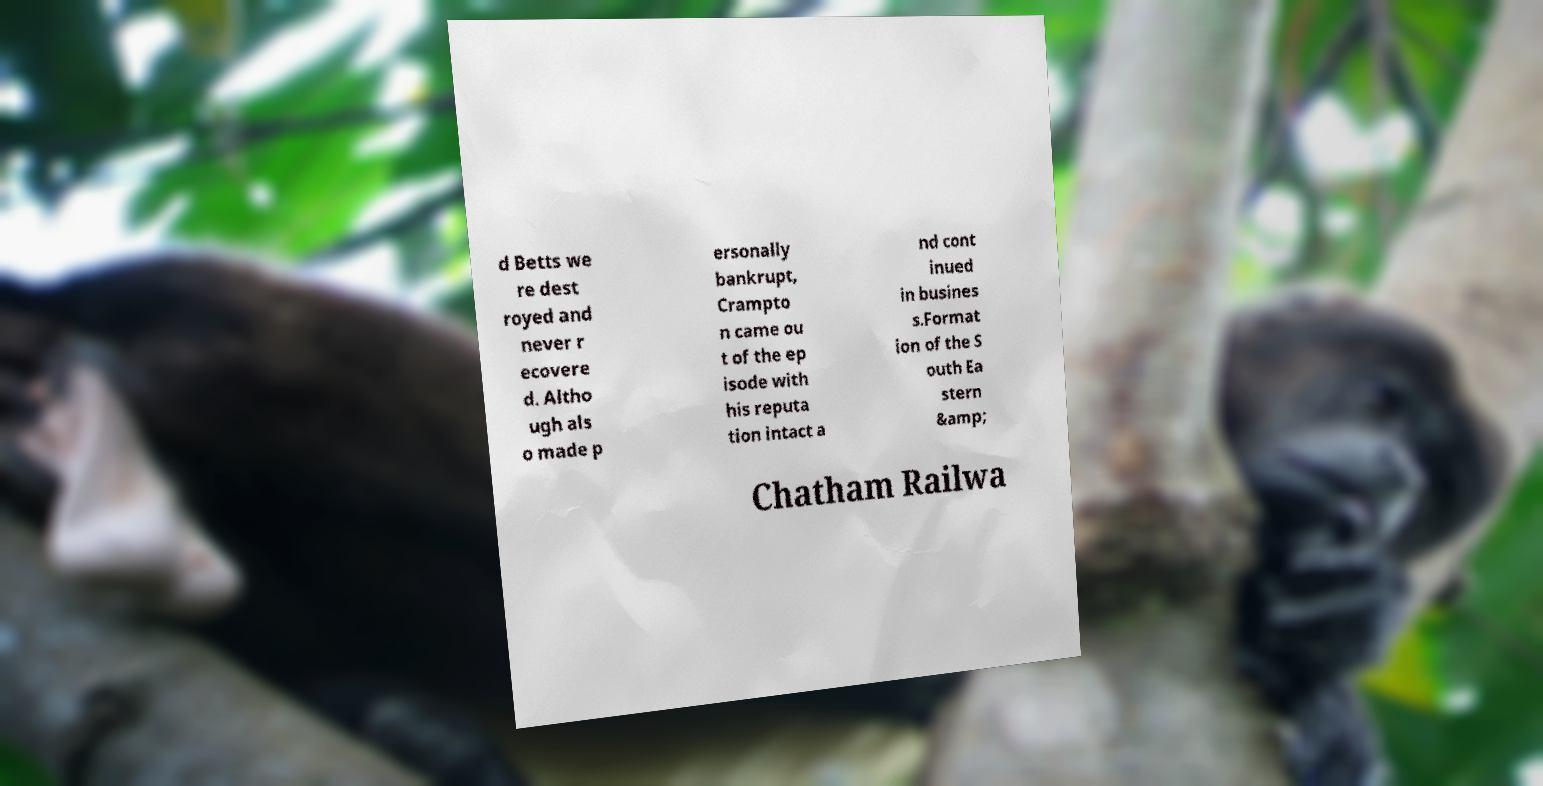Please identify and transcribe the text found in this image. d Betts we re dest royed and never r ecovere d. Altho ugh als o made p ersonally bankrupt, Crampto n came ou t of the ep isode with his reputa tion intact a nd cont inued in busines s.Format ion of the S outh Ea stern &amp; Chatham Railwa 